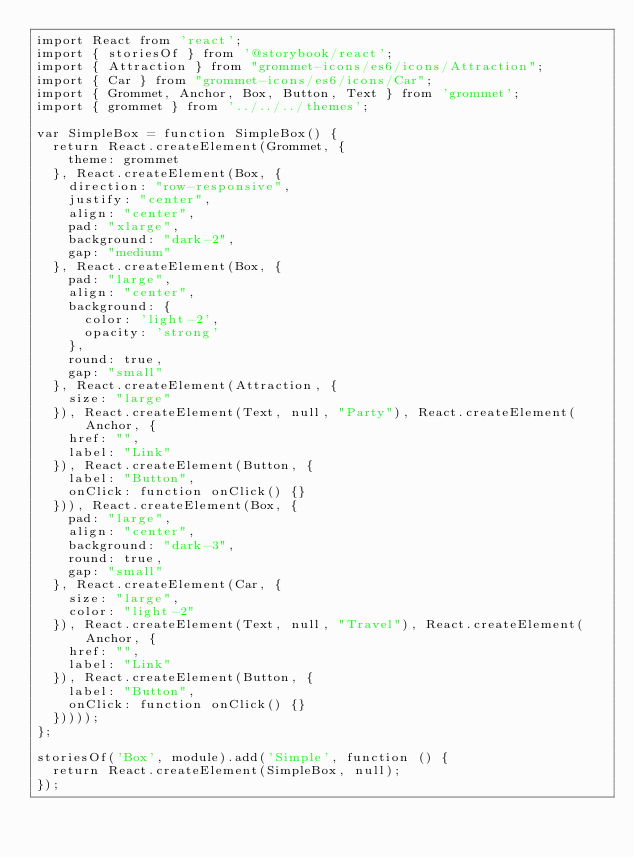<code> <loc_0><loc_0><loc_500><loc_500><_JavaScript_>import React from 'react';
import { storiesOf } from '@storybook/react';
import { Attraction } from "grommet-icons/es6/icons/Attraction";
import { Car } from "grommet-icons/es6/icons/Car";
import { Grommet, Anchor, Box, Button, Text } from 'grommet';
import { grommet } from '../../../themes';

var SimpleBox = function SimpleBox() {
  return React.createElement(Grommet, {
    theme: grommet
  }, React.createElement(Box, {
    direction: "row-responsive",
    justify: "center",
    align: "center",
    pad: "xlarge",
    background: "dark-2",
    gap: "medium"
  }, React.createElement(Box, {
    pad: "large",
    align: "center",
    background: {
      color: 'light-2',
      opacity: 'strong'
    },
    round: true,
    gap: "small"
  }, React.createElement(Attraction, {
    size: "large"
  }), React.createElement(Text, null, "Party"), React.createElement(Anchor, {
    href: "",
    label: "Link"
  }), React.createElement(Button, {
    label: "Button",
    onClick: function onClick() {}
  })), React.createElement(Box, {
    pad: "large",
    align: "center",
    background: "dark-3",
    round: true,
    gap: "small"
  }, React.createElement(Car, {
    size: "large",
    color: "light-2"
  }), React.createElement(Text, null, "Travel"), React.createElement(Anchor, {
    href: "",
    label: "Link"
  }), React.createElement(Button, {
    label: "Button",
    onClick: function onClick() {}
  }))));
};

storiesOf('Box', module).add('Simple', function () {
  return React.createElement(SimpleBox, null);
});</code> 